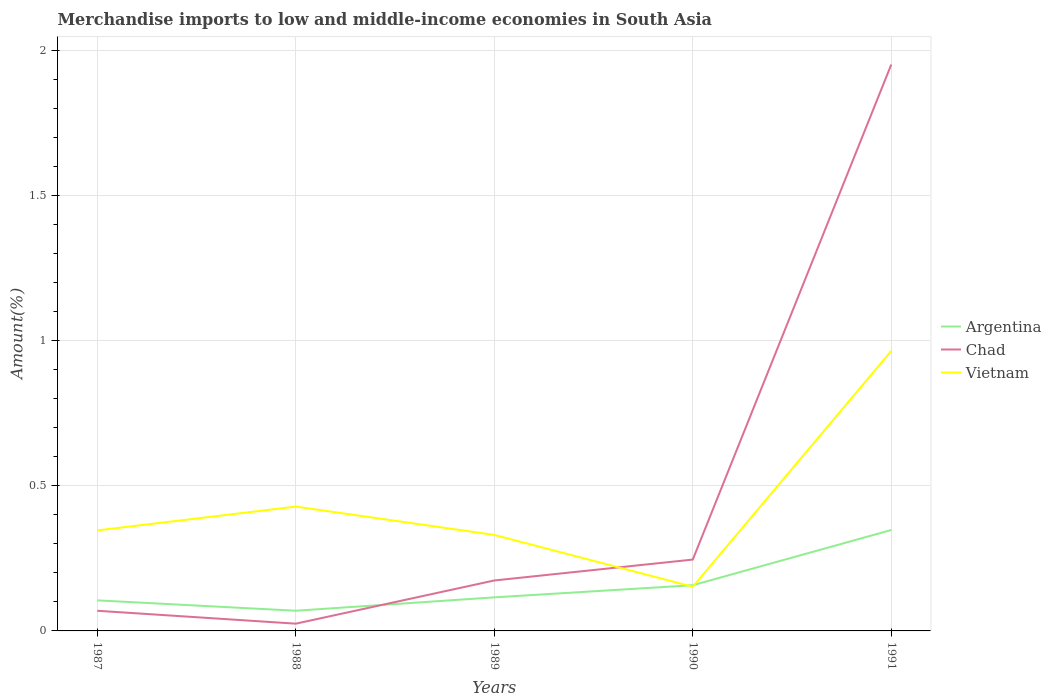Does the line corresponding to Vietnam intersect with the line corresponding to Argentina?
Make the answer very short. Yes. Is the number of lines equal to the number of legend labels?
Give a very brief answer. Yes. Across all years, what is the maximum percentage of amount earned from merchandise imports in Argentina?
Your answer should be compact. 0.07. What is the total percentage of amount earned from merchandise imports in Argentina in the graph?
Ensure brevity in your answer.  -0.04. What is the difference between the highest and the second highest percentage of amount earned from merchandise imports in Vietnam?
Make the answer very short. 0.81. Does the graph contain grids?
Offer a terse response. Yes. Where does the legend appear in the graph?
Offer a very short reply. Center right. How are the legend labels stacked?
Give a very brief answer. Vertical. What is the title of the graph?
Your answer should be very brief. Merchandise imports to low and middle-income economies in South Asia. Does "Least developed countries" appear as one of the legend labels in the graph?
Your answer should be very brief. No. What is the label or title of the Y-axis?
Offer a very short reply. Amount(%). What is the Amount(%) in Argentina in 1987?
Make the answer very short. 0.11. What is the Amount(%) in Chad in 1987?
Your answer should be compact. 0.07. What is the Amount(%) of Vietnam in 1987?
Give a very brief answer. 0.35. What is the Amount(%) of Argentina in 1988?
Keep it short and to the point. 0.07. What is the Amount(%) of Chad in 1988?
Keep it short and to the point. 0.02. What is the Amount(%) of Vietnam in 1988?
Your answer should be very brief. 0.43. What is the Amount(%) in Argentina in 1989?
Provide a succinct answer. 0.12. What is the Amount(%) in Chad in 1989?
Ensure brevity in your answer.  0.17. What is the Amount(%) of Vietnam in 1989?
Offer a very short reply. 0.33. What is the Amount(%) of Argentina in 1990?
Give a very brief answer. 0.16. What is the Amount(%) of Chad in 1990?
Your answer should be very brief. 0.25. What is the Amount(%) of Vietnam in 1990?
Give a very brief answer. 0.15. What is the Amount(%) of Argentina in 1991?
Your answer should be very brief. 0.35. What is the Amount(%) of Chad in 1991?
Provide a succinct answer. 1.95. What is the Amount(%) of Vietnam in 1991?
Offer a very short reply. 0.97. Across all years, what is the maximum Amount(%) in Argentina?
Provide a short and direct response. 0.35. Across all years, what is the maximum Amount(%) in Chad?
Your answer should be very brief. 1.95. Across all years, what is the maximum Amount(%) in Vietnam?
Your answer should be compact. 0.97. Across all years, what is the minimum Amount(%) in Argentina?
Provide a succinct answer. 0.07. Across all years, what is the minimum Amount(%) in Chad?
Provide a succinct answer. 0.02. Across all years, what is the minimum Amount(%) in Vietnam?
Your response must be concise. 0.15. What is the total Amount(%) of Argentina in the graph?
Offer a terse response. 0.8. What is the total Amount(%) of Chad in the graph?
Provide a succinct answer. 2.47. What is the total Amount(%) of Vietnam in the graph?
Your answer should be compact. 2.22. What is the difference between the Amount(%) of Argentina in 1987 and that in 1988?
Your answer should be compact. 0.04. What is the difference between the Amount(%) in Chad in 1987 and that in 1988?
Offer a very short reply. 0.04. What is the difference between the Amount(%) of Vietnam in 1987 and that in 1988?
Give a very brief answer. -0.08. What is the difference between the Amount(%) of Argentina in 1987 and that in 1989?
Make the answer very short. -0.01. What is the difference between the Amount(%) of Chad in 1987 and that in 1989?
Ensure brevity in your answer.  -0.1. What is the difference between the Amount(%) in Vietnam in 1987 and that in 1989?
Your response must be concise. 0.02. What is the difference between the Amount(%) of Argentina in 1987 and that in 1990?
Ensure brevity in your answer.  -0.05. What is the difference between the Amount(%) of Chad in 1987 and that in 1990?
Your response must be concise. -0.18. What is the difference between the Amount(%) in Vietnam in 1987 and that in 1990?
Provide a succinct answer. 0.19. What is the difference between the Amount(%) of Argentina in 1987 and that in 1991?
Offer a terse response. -0.24. What is the difference between the Amount(%) of Chad in 1987 and that in 1991?
Offer a very short reply. -1.88. What is the difference between the Amount(%) in Vietnam in 1987 and that in 1991?
Your response must be concise. -0.62. What is the difference between the Amount(%) of Argentina in 1988 and that in 1989?
Offer a terse response. -0.05. What is the difference between the Amount(%) in Chad in 1988 and that in 1989?
Keep it short and to the point. -0.15. What is the difference between the Amount(%) of Vietnam in 1988 and that in 1989?
Your answer should be compact. 0.1. What is the difference between the Amount(%) in Argentina in 1988 and that in 1990?
Ensure brevity in your answer.  -0.09. What is the difference between the Amount(%) of Chad in 1988 and that in 1990?
Give a very brief answer. -0.22. What is the difference between the Amount(%) of Vietnam in 1988 and that in 1990?
Provide a succinct answer. 0.28. What is the difference between the Amount(%) of Argentina in 1988 and that in 1991?
Provide a short and direct response. -0.28. What is the difference between the Amount(%) in Chad in 1988 and that in 1991?
Provide a short and direct response. -1.93. What is the difference between the Amount(%) in Vietnam in 1988 and that in 1991?
Make the answer very short. -0.54. What is the difference between the Amount(%) of Argentina in 1989 and that in 1990?
Make the answer very short. -0.04. What is the difference between the Amount(%) of Chad in 1989 and that in 1990?
Your response must be concise. -0.07. What is the difference between the Amount(%) of Vietnam in 1989 and that in 1990?
Provide a short and direct response. 0.18. What is the difference between the Amount(%) of Argentina in 1989 and that in 1991?
Your answer should be compact. -0.23. What is the difference between the Amount(%) in Chad in 1989 and that in 1991?
Provide a short and direct response. -1.78. What is the difference between the Amount(%) of Vietnam in 1989 and that in 1991?
Your answer should be very brief. -0.63. What is the difference between the Amount(%) of Argentina in 1990 and that in 1991?
Make the answer very short. -0.19. What is the difference between the Amount(%) in Chad in 1990 and that in 1991?
Your response must be concise. -1.71. What is the difference between the Amount(%) of Vietnam in 1990 and that in 1991?
Your answer should be compact. -0.81. What is the difference between the Amount(%) in Argentina in 1987 and the Amount(%) in Chad in 1988?
Provide a short and direct response. 0.08. What is the difference between the Amount(%) in Argentina in 1987 and the Amount(%) in Vietnam in 1988?
Keep it short and to the point. -0.32. What is the difference between the Amount(%) in Chad in 1987 and the Amount(%) in Vietnam in 1988?
Your answer should be very brief. -0.36. What is the difference between the Amount(%) in Argentina in 1987 and the Amount(%) in Chad in 1989?
Make the answer very short. -0.07. What is the difference between the Amount(%) of Argentina in 1987 and the Amount(%) of Vietnam in 1989?
Your answer should be compact. -0.23. What is the difference between the Amount(%) of Chad in 1987 and the Amount(%) of Vietnam in 1989?
Your answer should be very brief. -0.26. What is the difference between the Amount(%) of Argentina in 1987 and the Amount(%) of Chad in 1990?
Offer a terse response. -0.14. What is the difference between the Amount(%) of Argentina in 1987 and the Amount(%) of Vietnam in 1990?
Your answer should be compact. -0.05. What is the difference between the Amount(%) of Chad in 1987 and the Amount(%) of Vietnam in 1990?
Provide a succinct answer. -0.08. What is the difference between the Amount(%) of Argentina in 1987 and the Amount(%) of Chad in 1991?
Ensure brevity in your answer.  -1.85. What is the difference between the Amount(%) of Argentina in 1987 and the Amount(%) of Vietnam in 1991?
Offer a very short reply. -0.86. What is the difference between the Amount(%) of Chad in 1987 and the Amount(%) of Vietnam in 1991?
Your answer should be very brief. -0.9. What is the difference between the Amount(%) of Argentina in 1988 and the Amount(%) of Chad in 1989?
Offer a very short reply. -0.1. What is the difference between the Amount(%) in Argentina in 1988 and the Amount(%) in Vietnam in 1989?
Offer a terse response. -0.26. What is the difference between the Amount(%) of Chad in 1988 and the Amount(%) of Vietnam in 1989?
Your answer should be very brief. -0.31. What is the difference between the Amount(%) in Argentina in 1988 and the Amount(%) in Chad in 1990?
Your response must be concise. -0.18. What is the difference between the Amount(%) of Argentina in 1988 and the Amount(%) of Vietnam in 1990?
Offer a very short reply. -0.08. What is the difference between the Amount(%) of Chad in 1988 and the Amount(%) of Vietnam in 1990?
Offer a terse response. -0.13. What is the difference between the Amount(%) of Argentina in 1988 and the Amount(%) of Chad in 1991?
Offer a terse response. -1.88. What is the difference between the Amount(%) in Argentina in 1988 and the Amount(%) in Vietnam in 1991?
Your answer should be very brief. -0.9. What is the difference between the Amount(%) in Chad in 1988 and the Amount(%) in Vietnam in 1991?
Provide a succinct answer. -0.94. What is the difference between the Amount(%) in Argentina in 1989 and the Amount(%) in Chad in 1990?
Your answer should be very brief. -0.13. What is the difference between the Amount(%) in Argentina in 1989 and the Amount(%) in Vietnam in 1990?
Give a very brief answer. -0.04. What is the difference between the Amount(%) of Chad in 1989 and the Amount(%) of Vietnam in 1990?
Provide a succinct answer. 0.02. What is the difference between the Amount(%) in Argentina in 1989 and the Amount(%) in Chad in 1991?
Offer a very short reply. -1.84. What is the difference between the Amount(%) in Argentina in 1989 and the Amount(%) in Vietnam in 1991?
Ensure brevity in your answer.  -0.85. What is the difference between the Amount(%) in Chad in 1989 and the Amount(%) in Vietnam in 1991?
Your response must be concise. -0.79. What is the difference between the Amount(%) of Argentina in 1990 and the Amount(%) of Chad in 1991?
Ensure brevity in your answer.  -1.79. What is the difference between the Amount(%) of Argentina in 1990 and the Amount(%) of Vietnam in 1991?
Provide a short and direct response. -0.81. What is the difference between the Amount(%) in Chad in 1990 and the Amount(%) in Vietnam in 1991?
Provide a succinct answer. -0.72. What is the average Amount(%) of Argentina per year?
Keep it short and to the point. 0.16. What is the average Amount(%) in Chad per year?
Make the answer very short. 0.49. What is the average Amount(%) in Vietnam per year?
Make the answer very short. 0.44. In the year 1987, what is the difference between the Amount(%) in Argentina and Amount(%) in Chad?
Your answer should be very brief. 0.04. In the year 1987, what is the difference between the Amount(%) in Argentina and Amount(%) in Vietnam?
Offer a very short reply. -0.24. In the year 1987, what is the difference between the Amount(%) in Chad and Amount(%) in Vietnam?
Offer a terse response. -0.28. In the year 1988, what is the difference between the Amount(%) in Argentina and Amount(%) in Chad?
Your answer should be compact. 0.04. In the year 1988, what is the difference between the Amount(%) of Argentina and Amount(%) of Vietnam?
Offer a terse response. -0.36. In the year 1988, what is the difference between the Amount(%) in Chad and Amount(%) in Vietnam?
Your answer should be very brief. -0.4. In the year 1989, what is the difference between the Amount(%) of Argentina and Amount(%) of Chad?
Keep it short and to the point. -0.06. In the year 1989, what is the difference between the Amount(%) in Argentina and Amount(%) in Vietnam?
Give a very brief answer. -0.22. In the year 1989, what is the difference between the Amount(%) of Chad and Amount(%) of Vietnam?
Make the answer very short. -0.16. In the year 1990, what is the difference between the Amount(%) in Argentina and Amount(%) in Chad?
Make the answer very short. -0.09. In the year 1990, what is the difference between the Amount(%) in Argentina and Amount(%) in Vietnam?
Offer a terse response. 0.01. In the year 1990, what is the difference between the Amount(%) in Chad and Amount(%) in Vietnam?
Your answer should be very brief. 0.09. In the year 1991, what is the difference between the Amount(%) of Argentina and Amount(%) of Chad?
Give a very brief answer. -1.6. In the year 1991, what is the difference between the Amount(%) in Argentina and Amount(%) in Vietnam?
Provide a short and direct response. -0.62. In the year 1991, what is the difference between the Amount(%) in Chad and Amount(%) in Vietnam?
Give a very brief answer. 0.99. What is the ratio of the Amount(%) of Argentina in 1987 to that in 1988?
Your answer should be very brief. 1.51. What is the ratio of the Amount(%) in Chad in 1987 to that in 1988?
Keep it short and to the point. 2.78. What is the ratio of the Amount(%) in Vietnam in 1987 to that in 1988?
Your response must be concise. 0.81. What is the ratio of the Amount(%) of Argentina in 1987 to that in 1989?
Provide a succinct answer. 0.91. What is the ratio of the Amount(%) of Chad in 1987 to that in 1989?
Your answer should be very brief. 0.4. What is the ratio of the Amount(%) of Vietnam in 1987 to that in 1989?
Keep it short and to the point. 1.05. What is the ratio of the Amount(%) of Argentina in 1987 to that in 1990?
Make the answer very short. 0.67. What is the ratio of the Amount(%) of Chad in 1987 to that in 1990?
Provide a succinct answer. 0.28. What is the ratio of the Amount(%) in Vietnam in 1987 to that in 1990?
Your response must be concise. 2.28. What is the ratio of the Amount(%) in Argentina in 1987 to that in 1991?
Offer a very short reply. 0.3. What is the ratio of the Amount(%) of Chad in 1987 to that in 1991?
Give a very brief answer. 0.04. What is the ratio of the Amount(%) of Vietnam in 1987 to that in 1991?
Give a very brief answer. 0.36. What is the ratio of the Amount(%) of Argentina in 1988 to that in 1989?
Your answer should be very brief. 0.6. What is the ratio of the Amount(%) in Chad in 1988 to that in 1989?
Give a very brief answer. 0.14. What is the ratio of the Amount(%) in Vietnam in 1988 to that in 1989?
Your answer should be compact. 1.29. What is the ratio of the Amount(%) of Argentina in 1988 to that in 1990?
Provide a succinct answer. 0.44. What is the ratio of the Amount(%) in Chad in 1988 to that in 1990?
Give a very brief answer. 0.1. What is the ratio of the Amount(%) in Vietnam in 1988 to that in 1990?
Provide a short and direct response. 2.81. What is the ratio of the Amount(%) of Chad in 1988 to that in 1991?
Your answer should be compact. 0.01. What is the ratio of the Amount(%) in Vietnam in 1988 to that in 1991?
Give a very brief answer. 0.44. What is the ratio of the Amount(%) of Argentina in 1989 to that in 1990?
Offer a terse response. 0.73. What is the ratio of the Amount(%) of Chad in 1989 to that in 1990?
Your response must be concise. 0.71. What is the ratio of the Amount(%) of Vietnam in 1989 to that in 1990?
Your response must be concise. 2.17. What is the ratio of the Amount(%) of Argentina in 1989 to that in 1991?
Provide a short and direct response. 0.33. What is the ratio of the Amount(%) of Chad in 1989 to that in 1991?
Your answer should be very brief. 0.09. What is the ratio of the Amount(%) in Vietnam in 1989 to that in 1991?
Provide a succinct answer. 0.34. What is the ratio of the Amount(%) in Argentina in 1990 to that in 1991?
Your answer should be very brief. 0.45. What is the ratio of the Amount(%) of Chad in 1990 to that in 1991?
Your answer should be very brief. 0.13. What is the ratio of the Amount(%) in Vietnam in 1990 to that in 1991?
Your answer should be compact. 0.16. What is the difference between the highest and the second highest Amount(%) of Argentina?
Ensure brevity in your answer.  0.19. What is the difference between the highest and the second highest Amount(%) in Chad?
Your answer should be very brief. 1.71. What is the difference between the highest and the second highest Amount(%) in Vietnam?
Your response must be concise. 0.54. What is the difference between the highest and the lowest Amount(%) of Argentina?
Your answer should be compact. 0.28. What is the difference between the highest and the lowest Amount(%) of Chad?
Offer a very short reply. 1.93. What is the difference between the highest and the lowest Amount(%) of Vietnam?
Offer a terse response. 0.81. 